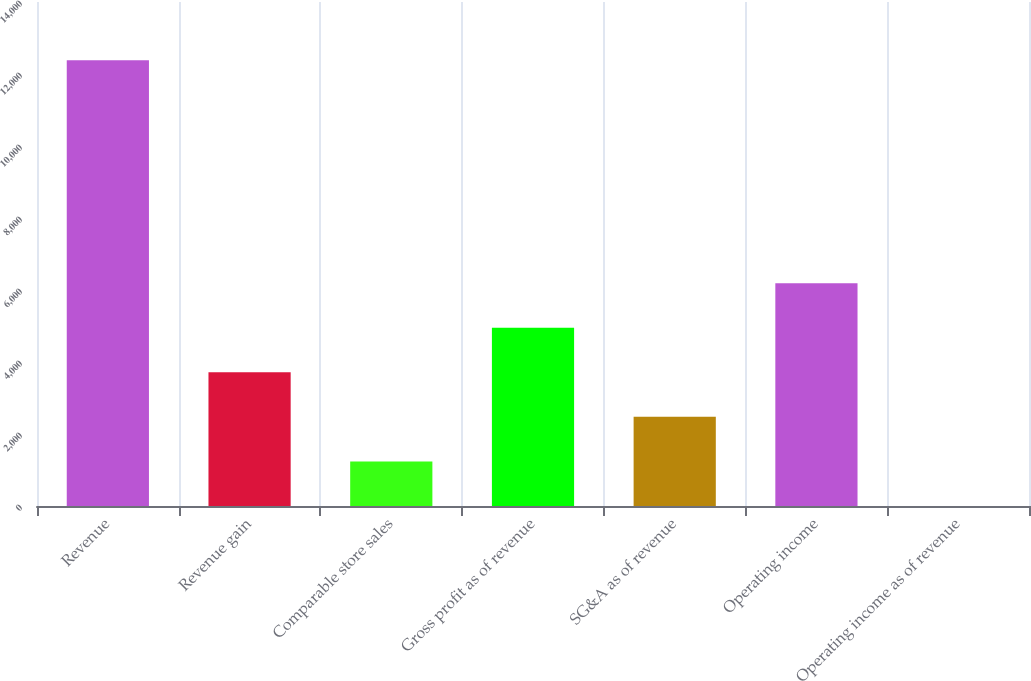Convert chart. <chart><loc_0><loc_0><loc_500><loc_500><bar_chart><fcel>Revenue<fcel>Revenue gain<fcel>Comparable store sales<fcel>Gross profit as of revenue<fcel>SG&A as of revenue<fcel>Operating income<fcel>Operating income as of revenue<nl><fcel>12380<fcel>3714.91<fcel>1239.17<fcel>4952.78<fcel>2477.04<fcel>6190.65<fcel>1.3<nl></chart> 